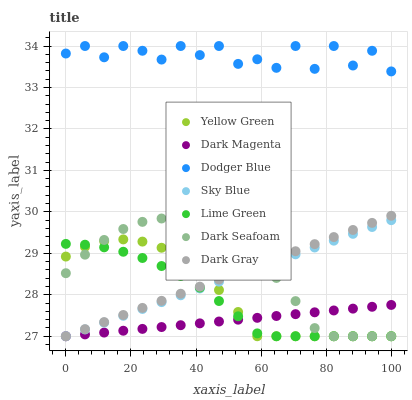Does Dark Magenta have the minimum area under the curve?
Answer yes or no. Yes. Does Dodger Blue have the maximum area under the curve?
Answer yes or no. Yes. Does Dark Gray have the minimum area under the curve?
Answer yes or no. No. Does Dark Gray have the maximum area under the curve?
Answer yes or no. No. Is Dark Gray the smoothest?
Answer yes or no. Yes. Is Dodger Blue the roughest?
Answer yes or no. Yes. Is Dark Seafoam the smoothest?
Answer yes or no. No. Is Dark Seafoam the roughest?
Answer yes or no. No. Does Yellow Green have the lowest value?
Answer yes or no. Yes. Does Dodger Blue have the lowest value?
Answer yes or no. No. Does Dodger Blue have the highest value?
Answer yes or no. Yes. Does Dark Gray have the highest value?
Answer yes or no. No. Is Yellow Green less than Dodger Blue?
Answer yes or no. Yes. Is Dodger Blue greater than Dark Gray?
Answer yes or no. Yes. Does Lime Green intersect Sky Blue?
Answer yes or no. Yes. Is Lime Green less than Sky Blue?
Answer yes or no. No. Is Lime Green greater than Sky Blue?
Answer yes or no. No. Does Yellow Green intersect Dodger Blue?
Answer yes or no. No. 